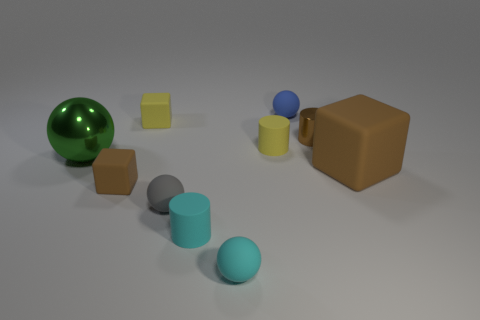Subtract all brown blocks. How many blocks are left? 1 Subtract all blue balls. How many balls are left? 3 Subtract all green cubes. How many yellow cylinders are left? 1 Subtract all big blue metal balls. Subtract all large green objects. How many objects are left? 9 Add 6 tiny shiny objects. How many tiny shiny objects are left? 7 Add 10 big blue cylinders. How many big blue cylinders exist? 10 Subtract 1 brown cylinders. How many objects are left? 9 Subtract all spheres. How many objects are left? 6 Subtract 2 spheres. How many spheres are left? 2 Subtract all gray balls. Subtract all green blocks. How many balls are left? 3 